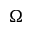Convert formula to latex. <formula><loc_0><loc_0><loc_500><loc_500>\Omega</formula> 